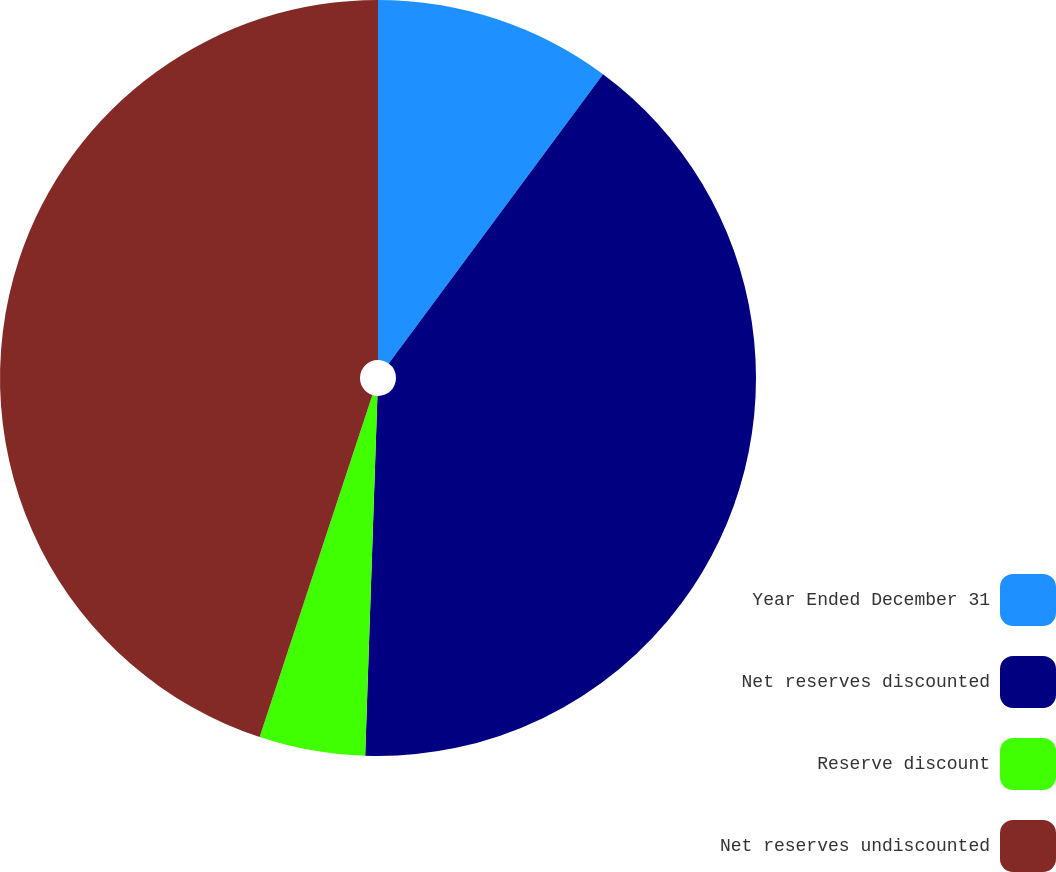<chart> <loc_0><loc_0><loc_500><loc_500><pie_chart><fcel>Year Ended December 31<fcel>Net reserves discounted<fcel>Reserve discount<fcel>Net reserves undiscounted<nl><fcel>10.15%<fcel>40.39%<fcel>4.53%<fcel>44.93%<nl></chart> 